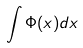Convert formula to latex. <formula><loc_0><loc_0><loc_500><loc_500>\int \Phi ( x ) d x</formula> 